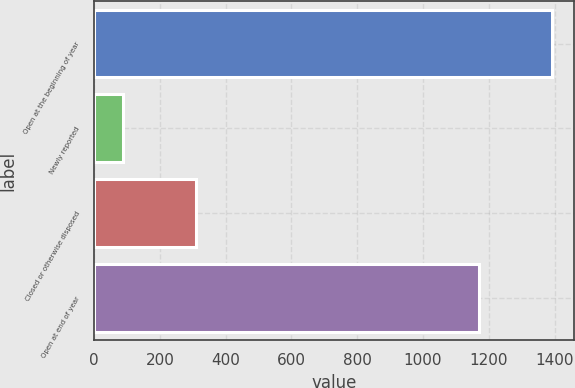<chart> <loc_0><loc_0><loc_500><loc_500><bar_chart><fcel>Open at the beginning of year<fcel>Newly reported<fcel>Closed or otherwise disposed<fcel>Open at end of year<nl><fcel>1391<fcel>87<fcel>309<fcel>1169<nl></chart> 